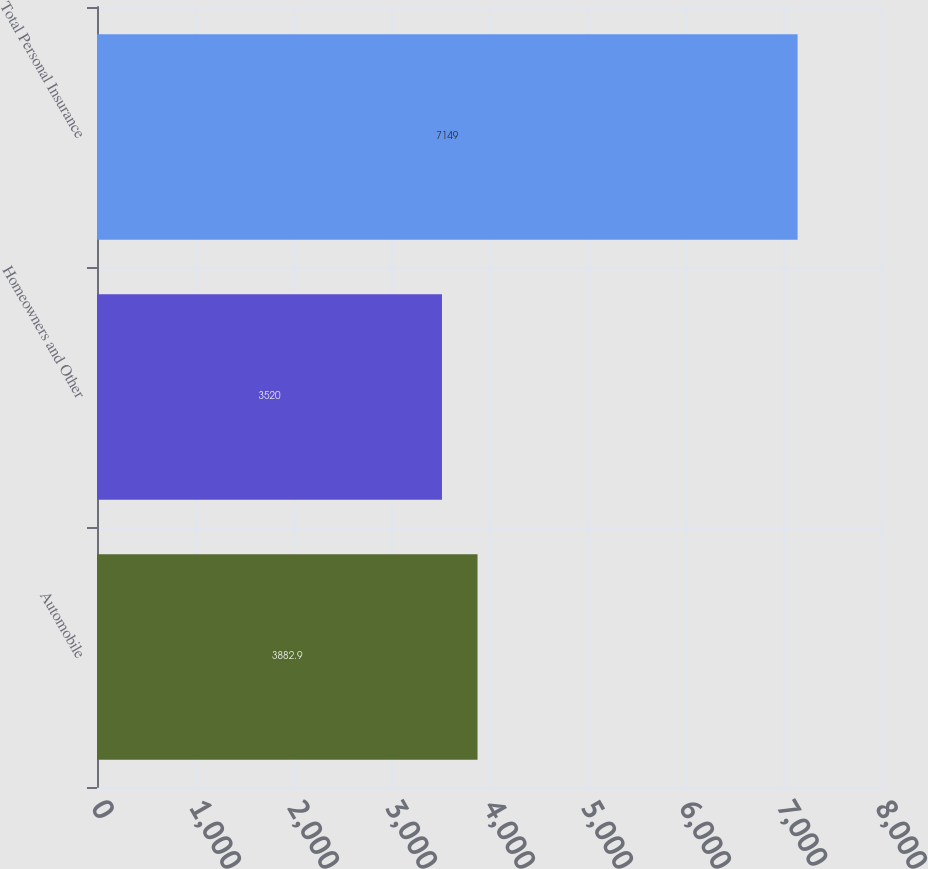Convert chart to OTSL. <chart><loc_0><loc_0><loc_500><loc_500><bar_chart><fcel>Automobile<fcel>Homeowners and Other<fcel>Total Personal Insurance<nl><fcel>3882.9<fcel>3520<fcel>7149<nl></chart> 